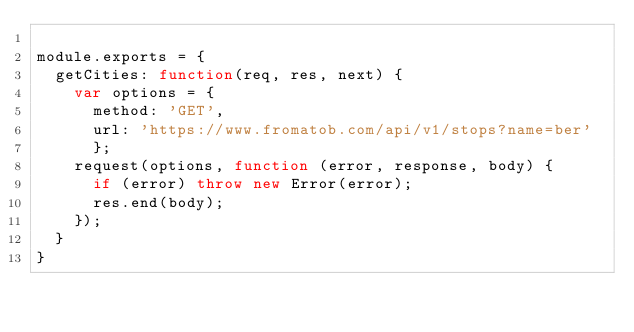Convert code to text. <code><loc_0><loc_0><loc_500><loc_500><_JavaScript_>
module.exports = {
  getCities: function(req, res, next) {
    var options = {
      method: 'GET',
      url: 'https://www.fromatob.com/api/v1/stops?name=ber'
      };
    request(options, function (error, response, body) {
      if (error) throw new Error(error);
      res.end(body);
    });
  }
}</code> 